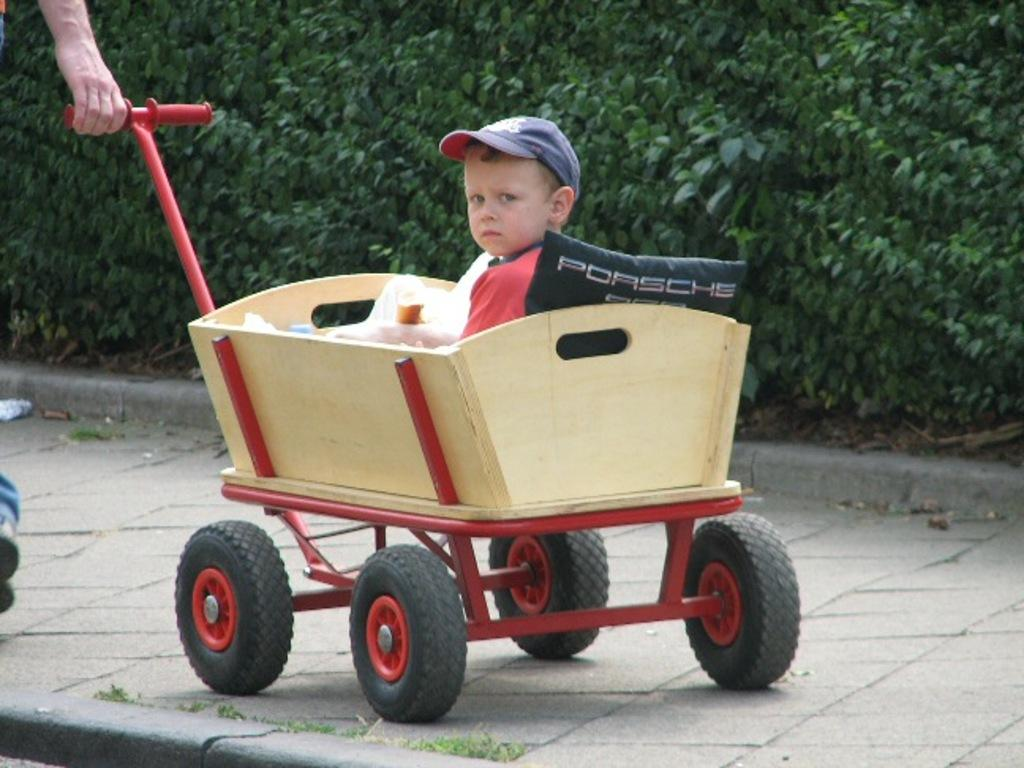What is the person in the image doing? The person in the image is pulling a cart. Who is in the cart? A boy is sitting in the cart. What is the boy wearing? The boy is wearing something. What can be seen in the background of the image? There are plants visible in the background of the image. How many brothers does the person pulling the cart have in the image? There is no information about the person's brothers in the image. Is there an oven visible in the image? There is no oven present in the image. 